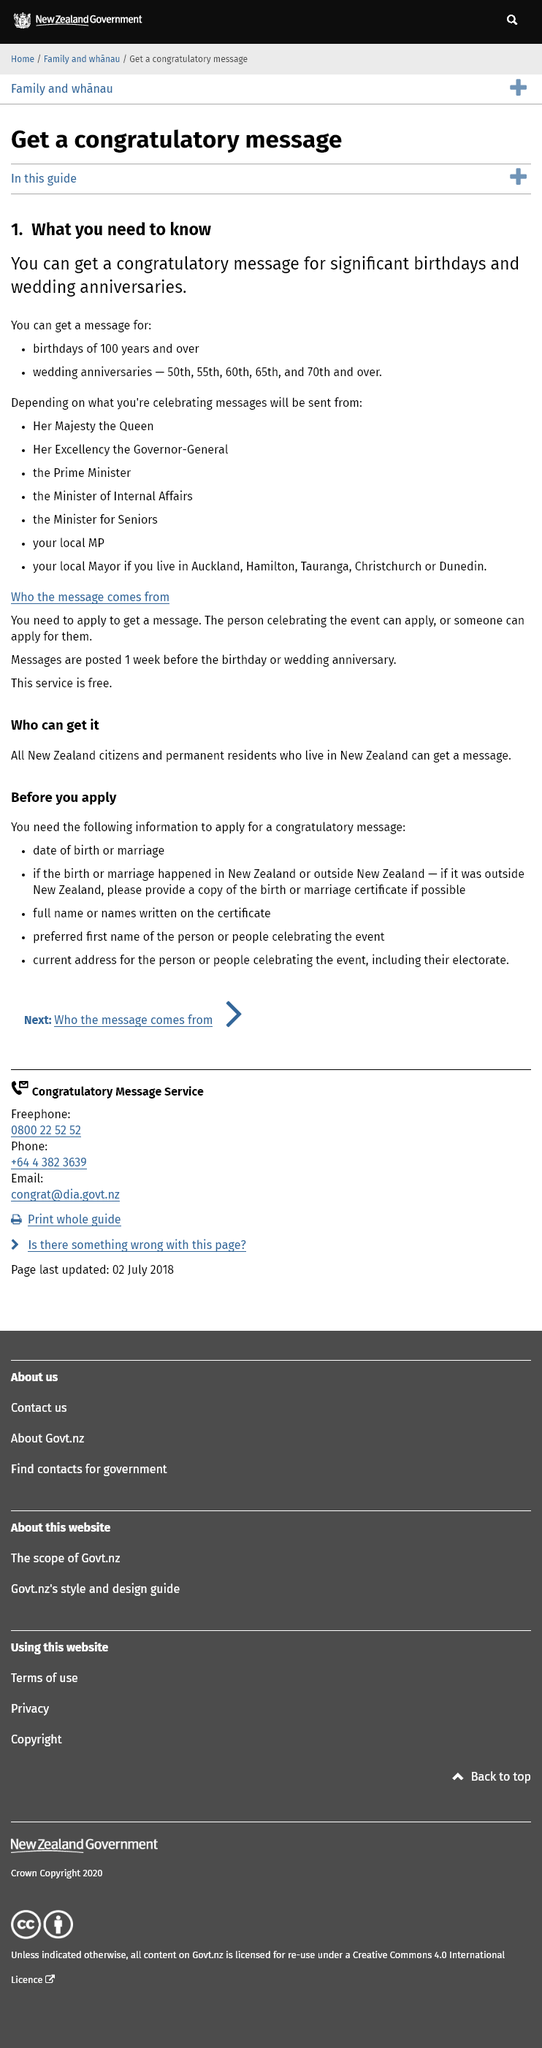Identify some key points in this picture. I can get birthday messages for those who have reached 100 years of age or older. The Queen may send a message of congratulations for a wedding anniversary, depending on the anniversary being celebrated. The Queen is not the only one to send congratulatory messages. Others who do so include the Governor-General, the Prime Minister, the Minister for Internal Affairs, the Minister for Seniors, your local MP, and your local mayor in some cities. 